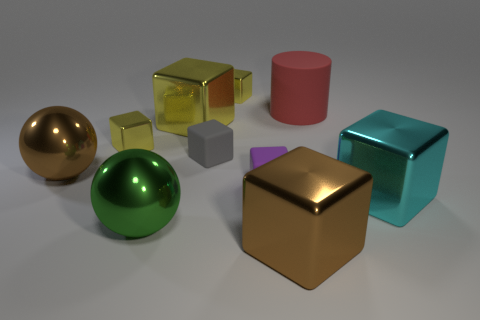How many yellow cubes must be subtracted to get 2 yellow cubes? 1 Subtract all yellow spheres. How many yellow cubes are left? 3 Subtract all matte blocks. How many blocks are left? 5 Subtract all gray blocks. How many blocks are left? 6 Subtract 3 blocks. How many blocks are left? 4 Subtract all cyan blocks. Subtract all cyan cylinders. How many blocks are left? 6 Subtract all cylinders. How many objects are left? 9 Subtract 1 yellow cubes. How many objects are left? 9 Subtract all small gray metal cylinders. Subtract all large brown blocks. How many objects are left? 9 Add 9 big yellow metal objects. How many big yellow metal objects are left? 10 